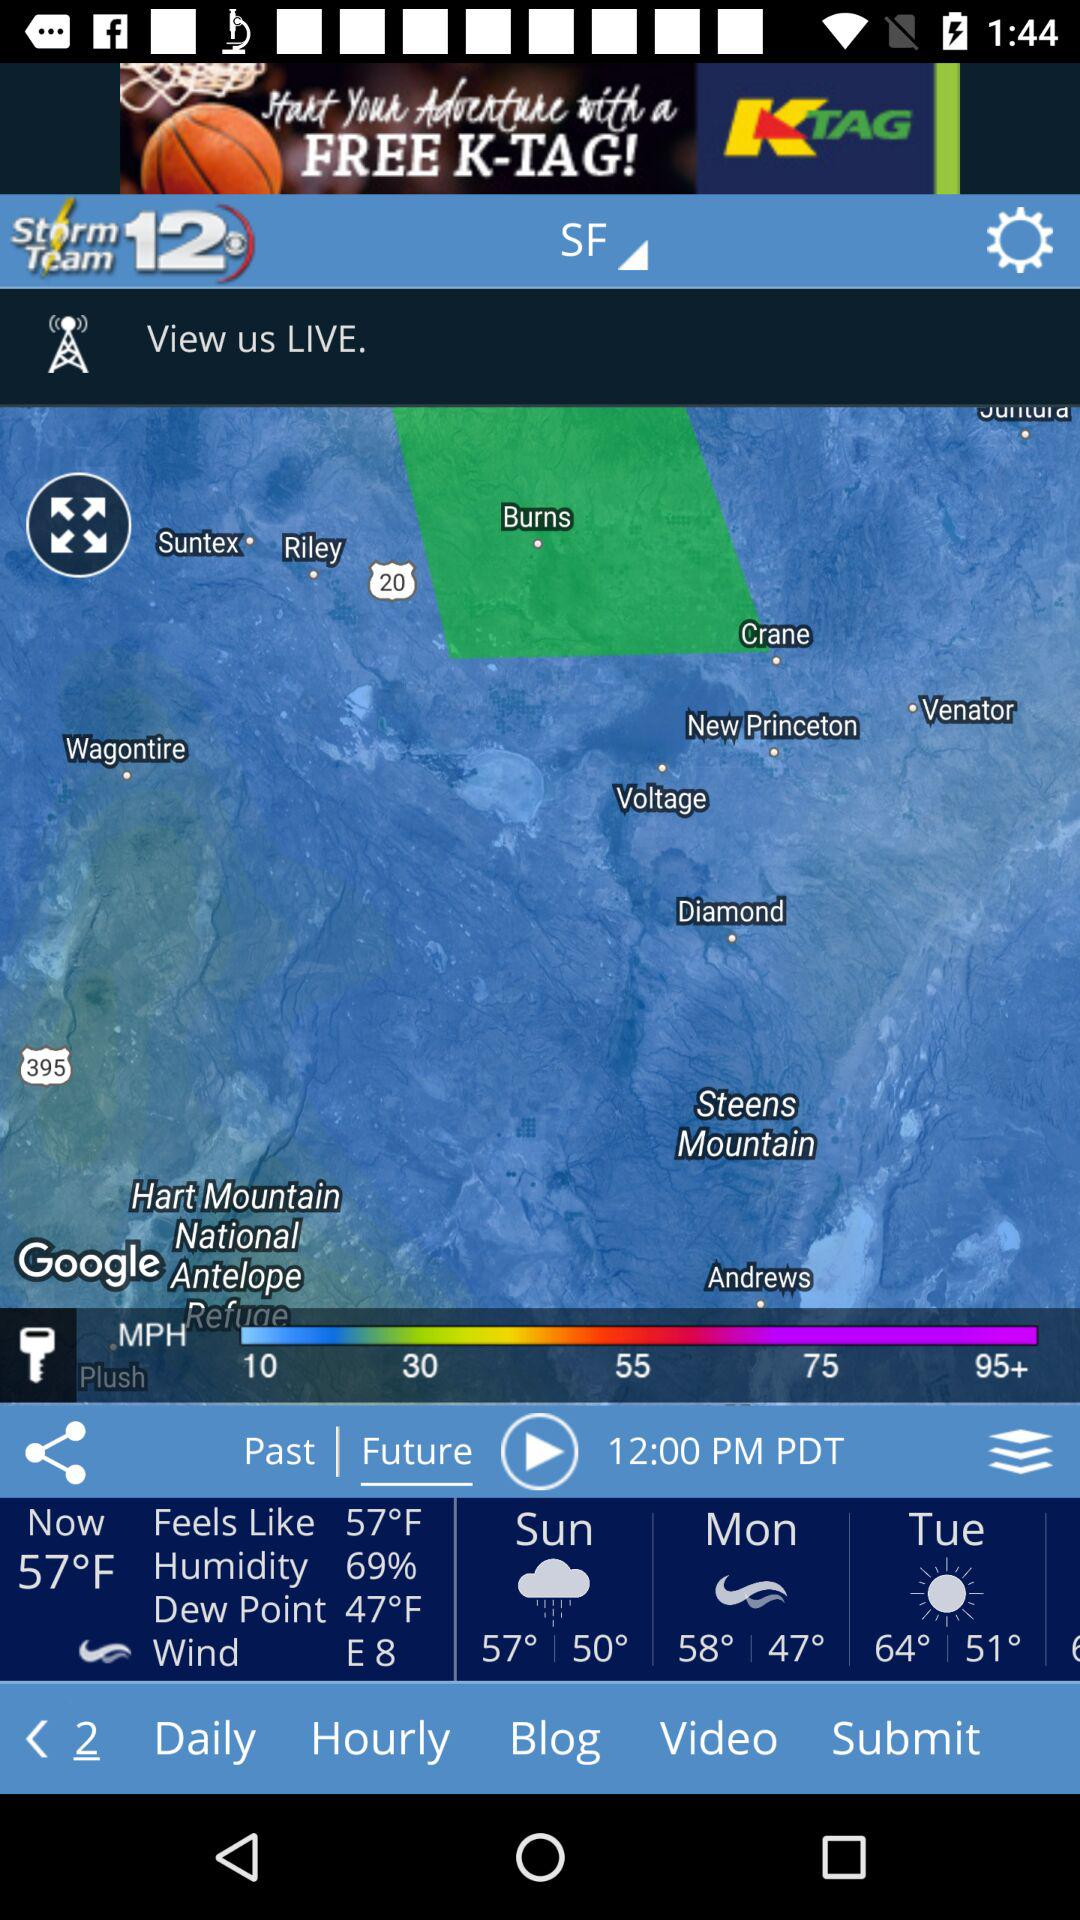How many more degrees is the high temperature than the low temperature?
Answer the question using a single word or phrase. 10 